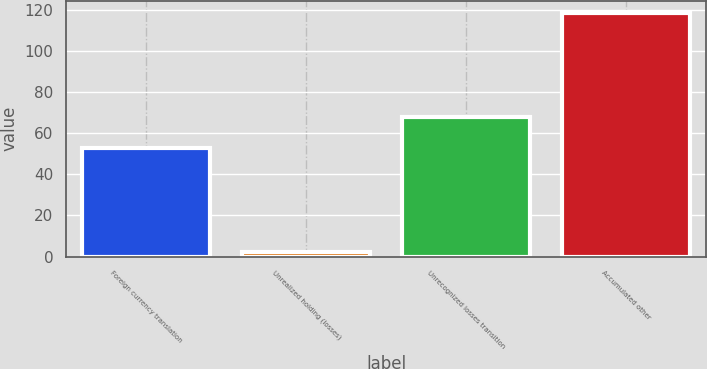Convert chart. <chart><loc_0><loc_0><loc_500><loc_500><bar_chart><fcel>Foreign currency translation<fcel>Unrealized holding (losses)<fcel>Unrecognized losses transition<fcel>Accumulated other<nl><fcel>53<fcel>2.2<fcel>67.8<fcel>118.6<nl></chart> 